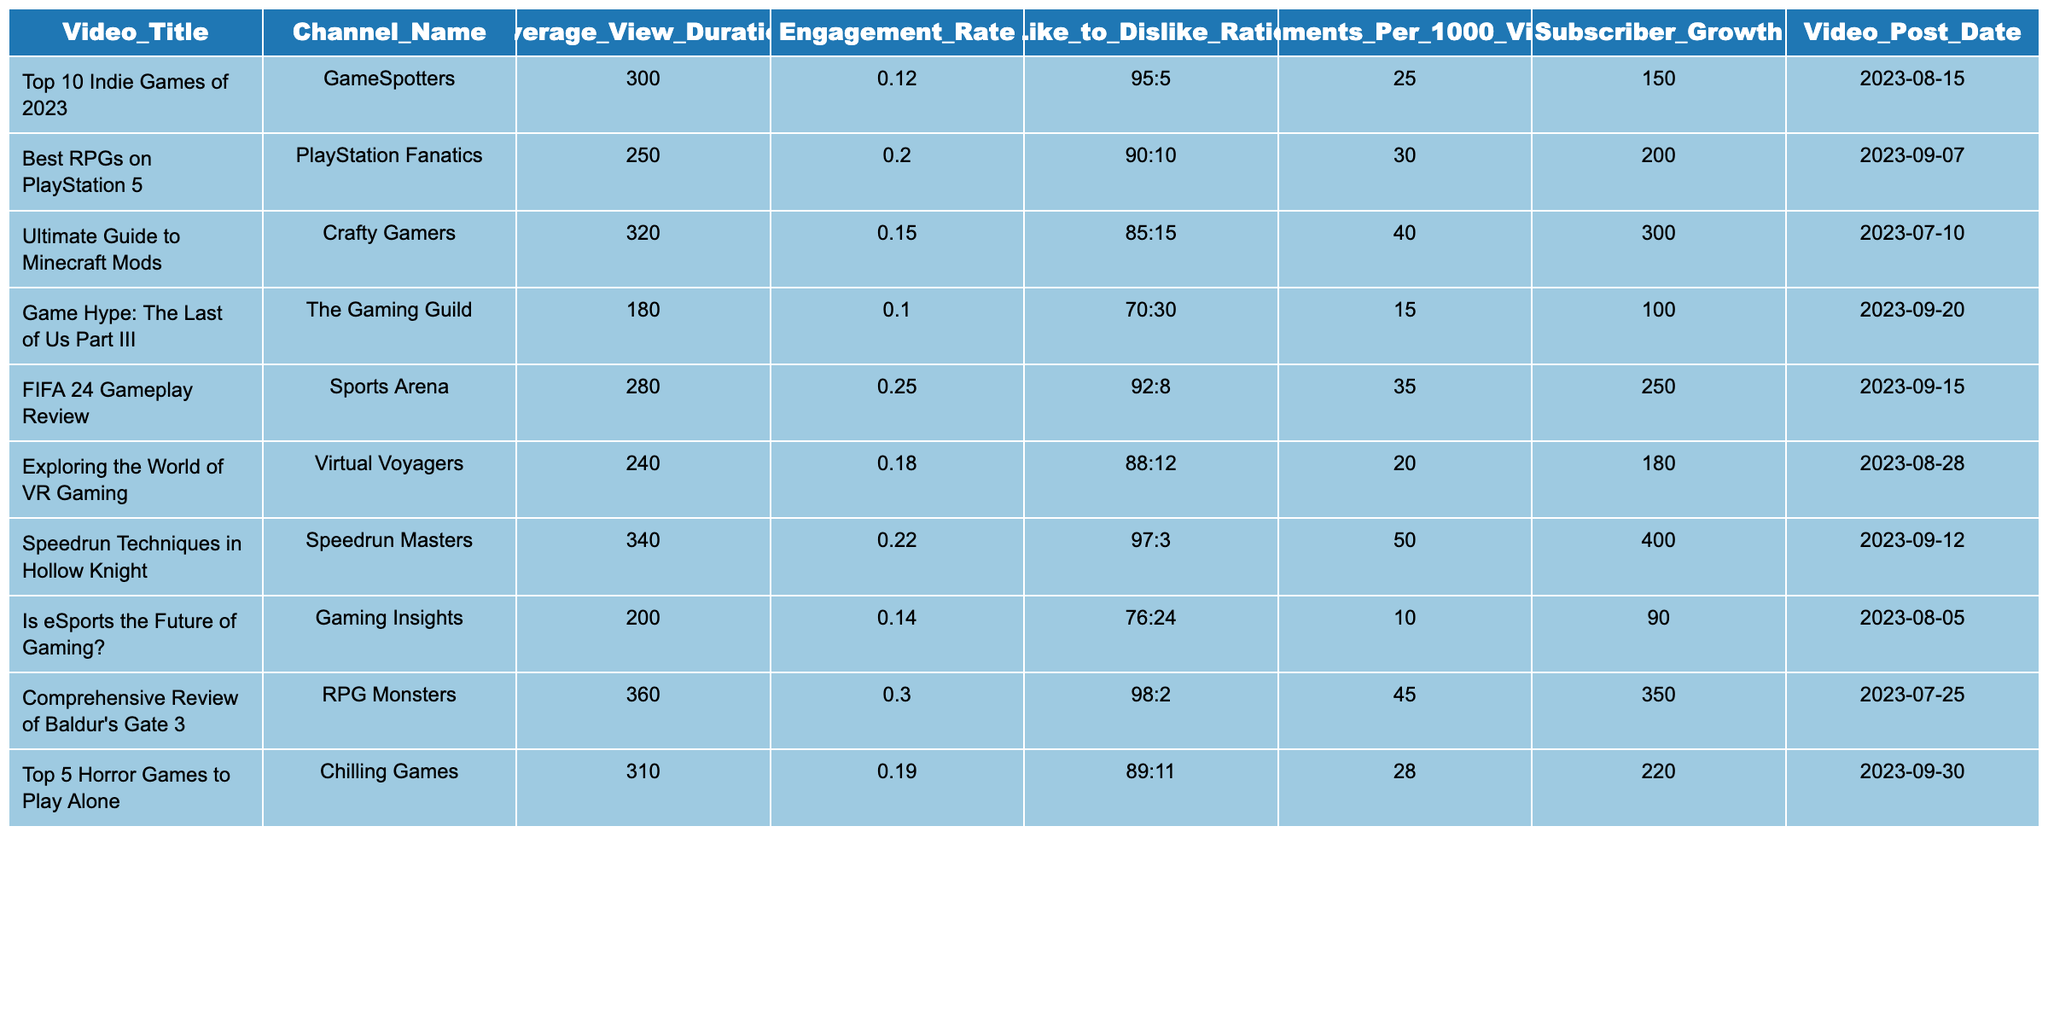What is the average view duration for "Speedrun Techniques in Hollow Knight"? The view duration for the video "Speedrun Techniques in Hollow Knight" is listed as 340 seconds.
Answer: 340 seconds Which video has the highest engagement rate? By comparing the engagement rates listed, "Comprehensive Review of Baldur's Gate 3" has the highest engagement rate of 0.30.
Answer: 0.30 What is the like-to-dislike ratio for "Game Hype: The Last of Us Part III"? The like-to-dislike ratio for that video is shown as 70:30.
Answer: 70:30 Is the subscriber growth for "Exploring the World of VR Gaming" greater than 150? The subscriber growth for that video is 180, which is greater than 150.
Answer: Yes What is the average comments per 1000 views for all videos listed? Adding up all the comments per 1000 views: (25 + 30 + 40 + 15 + 35 + 20 + 50 + 10 + 45 + 28) = 358. There are 10 videos, so the average is 358 / 10 = 35.8.
Answer: 35.8 Does "Top 5 Horror Games to Play Alone" have a higher average view duration than "Best RPGs on PlayStation 5"? "Top 5 Horror Games to Play Alone" has an average view duration of 310, while "Best RPGs on PlayStation 5" has 250, thus it is higher.
Answer: Yes What is the difference in subscriber growth between "Ultimate Guide to Minecraft Mods" and "FIFA 24 Gameplay Review"? The subscriber growth for "Ultimate Guide to Minecraft Mods" is 300 and for "FIFA 24 Gameplay Review" is 250. The difference is 300 - 250 = 50.
Answer: 50 Which channel has the least comments per 1000 views? Checking the comments per 1000 views, "Is eSports the Future of Gaming?" has the least at 10 comments.
Answer: Is eSports the Future of Gaming? What is the total subscriber growth of all videos in the table? Adding all the subscriber growth values: (150 + 200 + 300 + 100 + 250 + 180 + 400 + 90 + 350 + 220) = 2240.
Answer: 2240 Which video was posted most recently? The video "Top 5 Horror Games to Play Alone" was posted on 2023-09-30, making it the most recent.
Answer: Top 5 Horror Games to Play Alone 